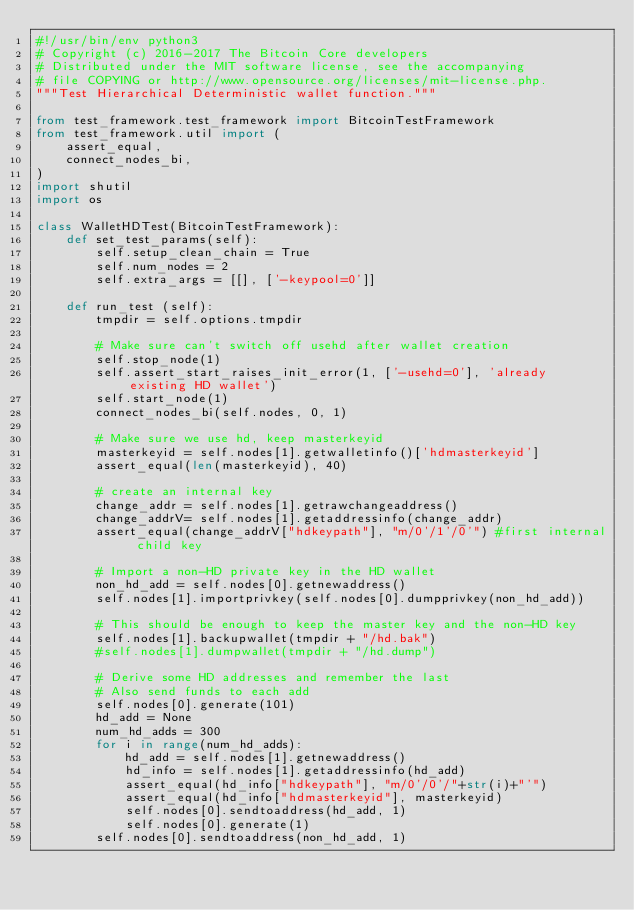<code> <loc_0><loc_0><loc_500><loc_500><_Python_>#!/usr/bin/env python3
# Copyright (c) 2016-2017 The Bitcoin Core developers
# Distributed under the MIT software license, see the accompanying
# file COPYING or http://www.opensource.org/licenses/mit-license.php.
"""Test Hierarchical Deterministic wallet function."""

from test_framework.test_framework import BitcoinTestFramework
from test_framework.util import (
    assert_equal,
    connect_nodes_bi,
)
import shutil
import os

class WalletHDTest(BitcoinTestFramework):
    def set_test_params(self):
        self.setup_clean_chain = True
        self.num_nodes = 2
        self.extra_args = [[], ['-keypool=0']]

    def run_test (self):
        tmpdir = self.options.tmpdir

        # Make sure can't switch off usehd after wallet creation
        self.stop_node(1)
        self.assert_start_raises_init_error(1, ['-usehd=0'], 'already existing HD wallet')
        self.start_node(1)
        connect_nodes_bi(self.nodes, 0, 1)

        # Make sure we use hd, keep masterkeyid
        masterkeyid = self.nodes[1].getwalletinfo()['hdmasterkeyid']
        assert_equal(len(masterkeyid), 40)

        # create an internal key
        change_addr = self.nodes[1].getrawchangeaddress()
        change_addrV= self.nodes[1].getaddressinfo(change_addr)
        assert_equal(change_addrV["hdkeypath"], "m/0'/1'/0'") #first internal child key

        # Import a non-HD private key in the HD wallet
        non_hd_add = self.nodes[0].getnewaddress()
        self.nodes[1].importprivkey(self.nodes[0].dumpprivkey(non_hd_add))

        # This should be enough to keep the master key and the non-HD key
        self.nodes[1].backupwallet(tmpdir + "/hd.bak")
        #self.nodes[1].dumpwallet(tmpdir + "/hd.dump")

        # Derive some HD addresses and remember the last
        # Also send funds to each add
        self.nodes[0].generate(101)
        hd_add = None
        num_hd_adds = 300
        for i in range(num_hd_adds):
            hd_add = self.nodes[1].getnewaddress()
            hd_info = self.nodes[1].getaddressinfo(hd_add)
            assert_equal(hd_info["hdkeypath"], "m/0'/0'/"+str(i)+"'")
            assert_equal(hd_info["hdmasterkeyid"], masterkeyid)
            self.nodes[0].sendtoaddress(hd_add, 1)
            self.nodes[0].generate(1)
        self.nodes[0].sendtoaddress(non_hd_add, 1)</code> 